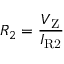Convert formula to latex. <formula><loc_0><loc_0><loc_500><loc_500>R _ { 2 } = { \frac { V _ { Z } } { I _ { R 2 } } }</formula> 